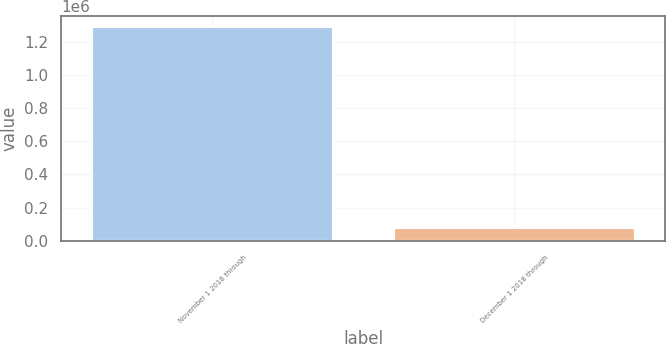Convert chart to OTSL. <chart><loc_0><loc_0><loc_500><loc_500><bar_chart><fcel>November 1 2018 through<fcel>December 1 2018 through<nl><fcel>1.29175e+06<fcel>81875<nl></chart> 